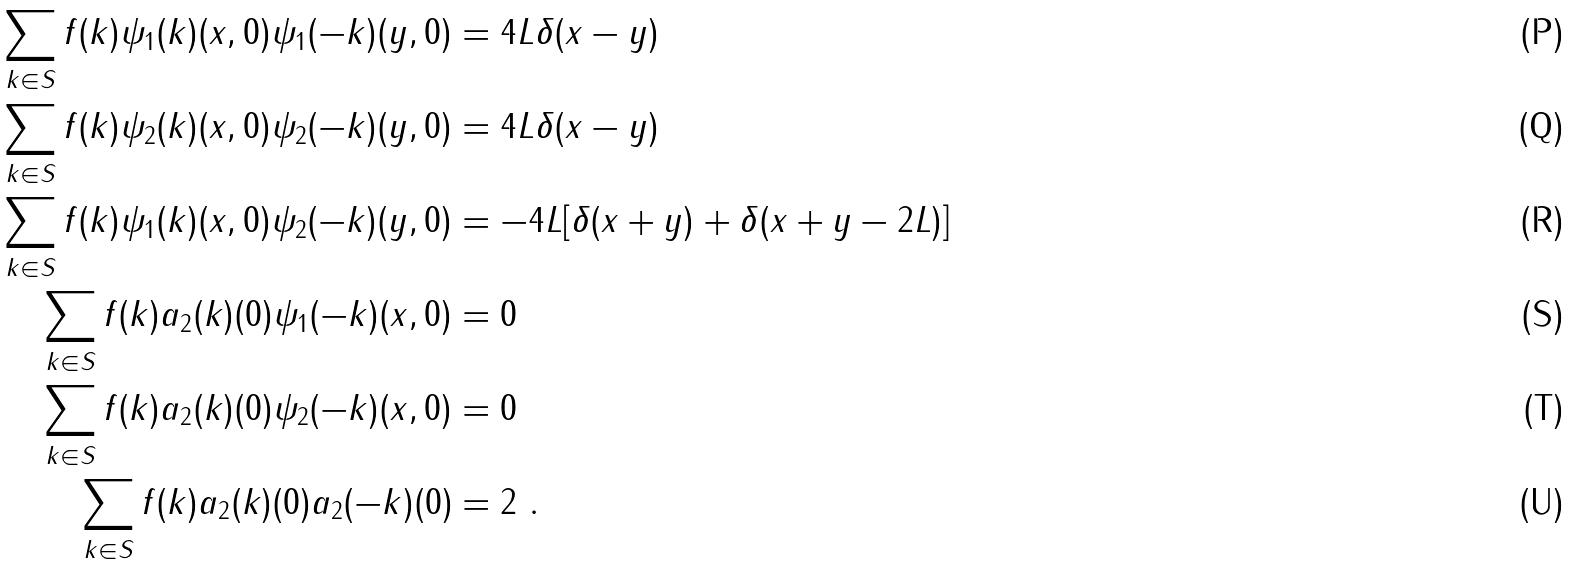<formula> <loc_0><loc_0><loc_500><loc_500>\sum _ { k \in S } f ( k ) \psi _ { 1 } ( k ) ( x , 0 ) \psi _ { 1 } ( - k ) ( y , 0 ) & = 4 L \delta ( x - y ) \\ \sum _ { k \in S } f ( k ) \psi _ { 2 } ( k ) ( x , 0 ) \psi _ { 2 } ( - k ) ( y , 0 ) & = 4 L \delta ( x - y ) \\ \sum _ { k \in S } f ( k ) \psi _ { 1 } ( k ) ( x , 0 ) \psi _ { 2 } ( - k ) ( y , 0 ) & = - 4 L [ \delta ( x + y ) + \delta ( x + y - 2 L ) ] \\ \sum _ { k \in S } f ( k ) a _ { 2 } ( k ) ( 0 ) \psi _ { 1 } ( - k ) ( x , 0 ) & = 0 \\ \sum _ { k \in S } f ( k ) a _ { 2 } ( k ) ( 0 ) \psi _ { 2 } ( - k ) ( x , 0 ) & = 0 \\ \sum _ { k \in S } f ( k ) a _ { 2 } ( k ) ( 0 ) a _ { 2 } ( - k ) ( 0 ) & = 2 \ .</formula> 